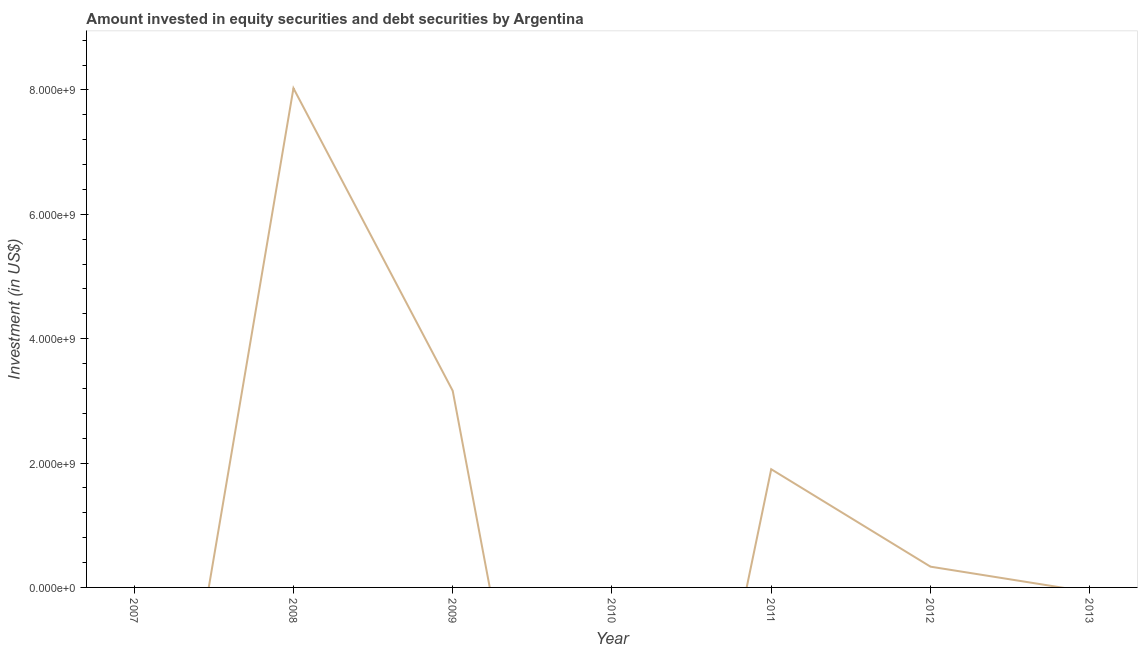What is the portfolio investment in 2009?
Ensure brevity in your answer.  3.16e+09. Across all years, what is the maximum portfolio investment?
Your response must be concise. 8.03e+09. In which year was the portfolio investment maximum?
Make the answer very short. 2008. What is the sum of the portfolio investment?
Ensure brevity in your answer.  1.34e+1. What is the difference between the portfolio investment in 2008 and 2011?
Provide a succinct answer. 6.13e+09. What is the average portfolio investment per year?
Your response must be concise. 1.92e+09. What is the median portfolio investment?
Provide a succinct answer. 3.34e+08. In how many years, is the portfolio investment greater than 6000000000 US$?
Your answer should be very brief. 1. What is the ratio of the portfolio investment in 2009 to that in 2011?
Offer a very short reply. 1.66. What is the difference between the highest and the second highest portfolio investment?
Your answer should be compact. 4.87e+09. Is the sum of the portfolio investment in 2009 and 2012 greater than the maximum portfolio investment across all years?
Ensure brevity in your answer.  No. What is the difference between the highest and the lowest portfolio investment?
Ensure brevity in your answer.  8.03e+09. Does the portfolio investment monotonically increase over the years?
Ensure brevity in your answer.  No. What is the difference between two consecutive major ticks on the Y-axis?
Your answer should be very brief. 2.00e+09. Are the values on the major ticks of Y-axis written in scientific E-notation?
Provide a short and direct response. Yes. Does the graph contain any zero values?
Your answer should be very brief. Yes. Does the graph contain grids?
Your answer should be compact. No. What is the title of the graph?
Keep it short and to the point. Amount invested in equity securities and debt securities by Argentina. What is the label or title of the Y-axis?
Ensure brevity in your answer.  Investment (in US$). What is the Investment (in US$) in 2008?
Give a very brief answer. 8.03e+09. What is the Investment (in US$) of 2009?
Ensure brevity in your answer.  3.16e+09. What is the Investment (in US$) of 2010?
Offer a terse response. 0. What is the Investment (in US$) in 2011?
Keep it short and to the point. 1.90e+09. What is the Investment (in US$) of 2012?
Offer a very short reply. 3.34e+08. What is the difference between the Investment (in US$) in 2008 and 2009?
Keep it short and to the point. 4.87e+09. What is the difference between the Investment (in US$) in 2008 and 2011?
Offer a very short reply. 6.13e+09. What is the difference between the Investment (in US$) in 2008 and 2012?
Give a very brief answer. 7.69e+09. What is the difference between the Investment (in US$) in 2009 and 2011?
Make the answer very short. 1.26e+09. What is the difference between the Investment (in US$) in 2009 and 2012?
Provide a succinct answer. 2.83e+09. What is the difference between the Investment (in US$) in 2011 and 2012?
Keep it short and to the point. 1.57e+09. What is the ratio of the Investment (in US$) in 2008 to that in 2009?
Your answer should be very brief. 2.54. What is the ratio of the Investment (in US$) in 2008 to that in 2011?
Provide a succinct answer. 4.22. What is the ratio of the Investment (in US$) in 2008 to that in 2012?
Offer a terse response. 24.04. What is the ratio of the Investment (in US$) in 2009 to that in 2011?
Your answer should be compact. 1.66. What is the ratio of the Investment (in US$) in 2009 to that in 2012?
Offer a very short reply. 9.47. What is the ratio of the Investment (in US$) in 2011 to that in 2012?
Your answer should be very brief. 5.69. 